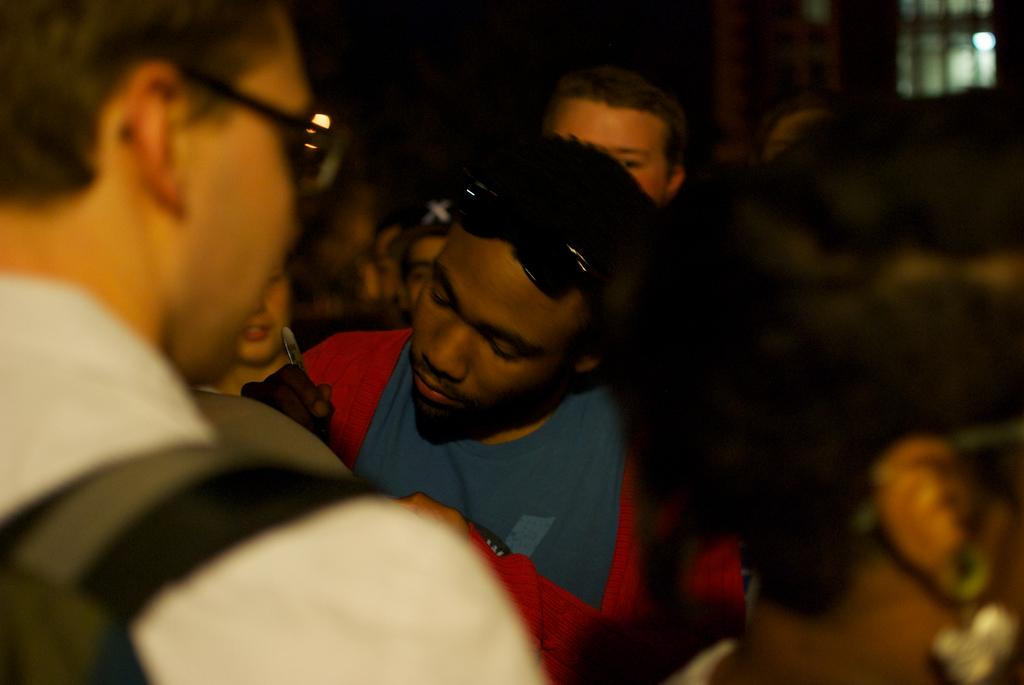How many people are in the image? There is a group of people in the image. Can you describe the clothing of one person in the group? One person in the group is wearing a green color shirt. What is the color of the background in the image? The background of the image is dark. What is the name of the person wearing the veil in the image? There is no person wearing a veil in the image. Can you tell me how many laps the person is swimming in the image? There is no swimming or person swimming in the image. 